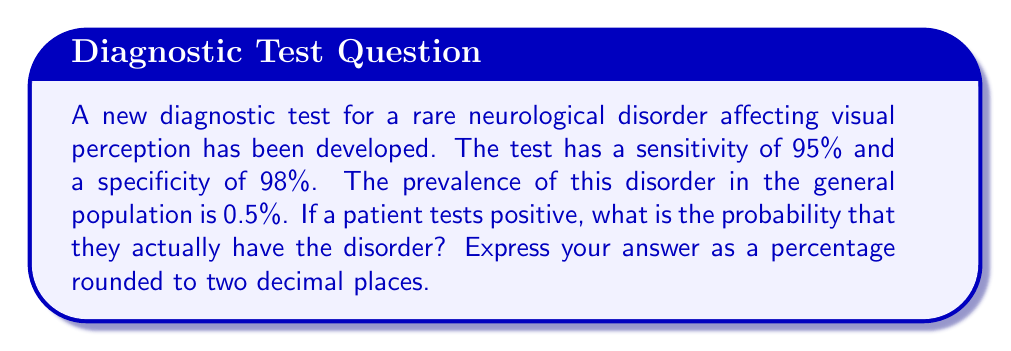Could you help me with this problem? Let's approach this step-by-step using Bayes' theorem:

1) Let's define our events:
   A = Having the disorder
   B = Testing positive

2) We're given:
   P(B|A) = Sensitivity = 0.95
   P(B|not A) = 1 - Specificity = 1 - 0.98 = 0.02
   P(A) = Prevalence = 0.005

3) We want to find P(A|B), which is given by Bayes' theorem:

   $$P(A|B) = \frac{P(B|A) \cdot P(A)}{P(B)}$$

4) We need to calculate P(B):
   P(B) = P(B|A) · P(A) + P(B|not A) · P(not A)
        = 0.95 · 0.005 + 0.02 · 0.995
        = 0.00475 + 0.0199
        = 0.02465

5) Now we can apply Bayes' theorem:

   $$P(A|B) = \frac{0.95 \cdot 0.005}{0.02465} = 0.1927$$

6) Converting to a percentage and rounding to two decimal places:
   0.1927 * 100 = 19.27%
Answer: 19.27% 